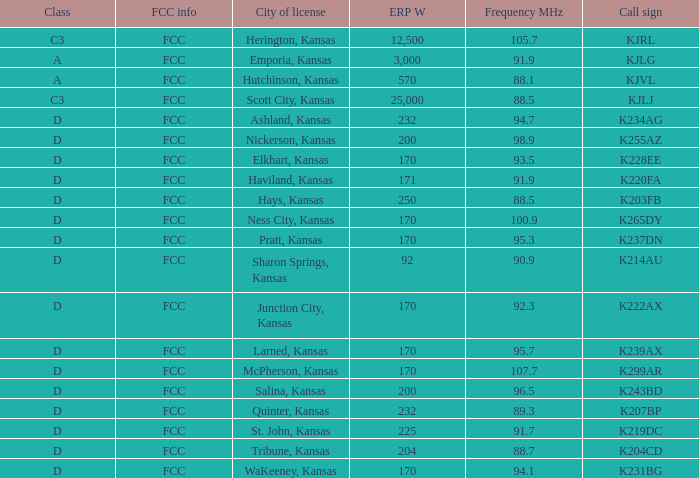Frequency MHz of 88.7 had what average erp w? 204.0. 